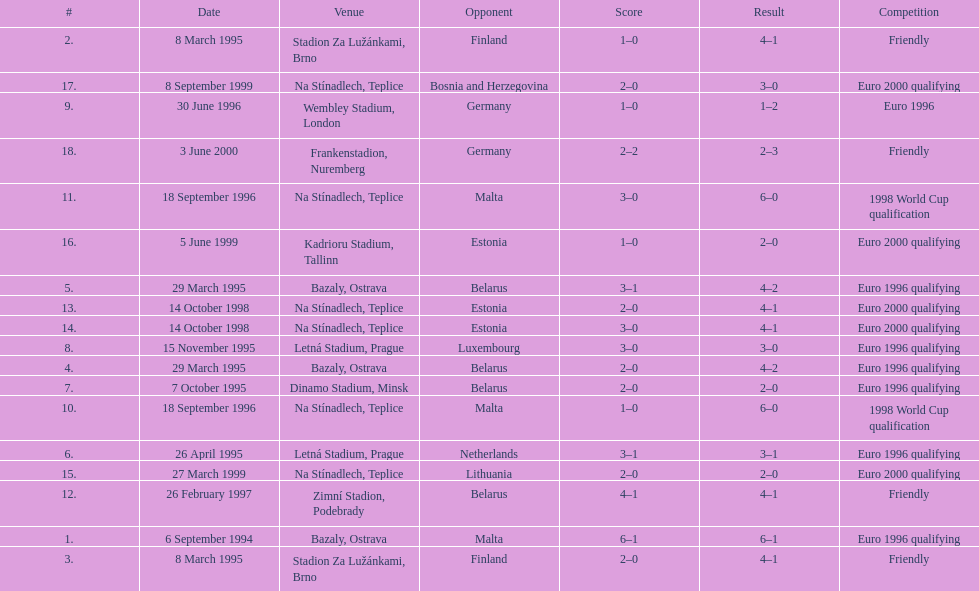How many total games took place in 1999? 3. 